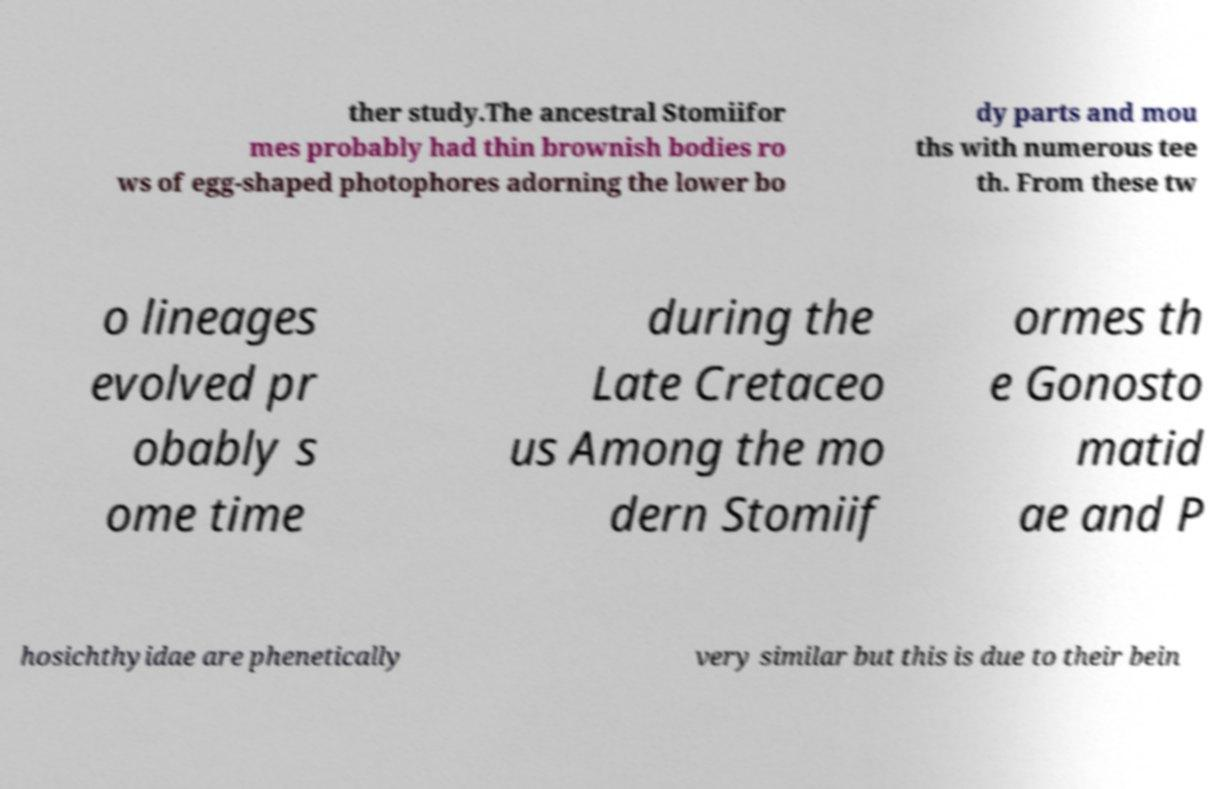Please read and relay the text visible in this image. What does it say? ther study.The ancestral Stomiifor mes probably had thin brownish bodies ro ws of egg-shaped photophores adorning the lower bo dy parts and mou ths with numerous tee th. From these tw o lineages evolved pr obably s ome time during the Late Cretaceo us Among the mo dern Stomiif ormes th e Gonosto matid ae and P hosichthyidae are phenetically very similar but this is due to their bein 